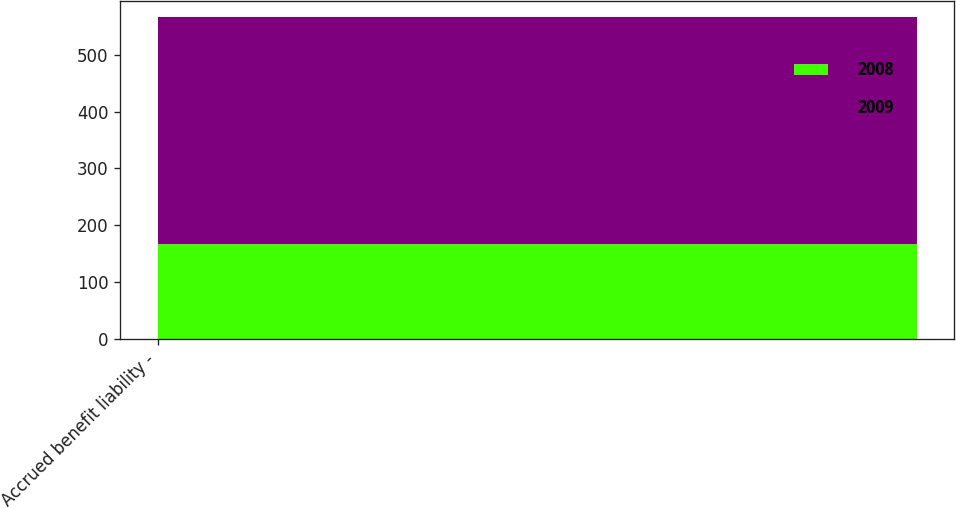Convert chart. <chart><loc_0><loc_0><loc_500><loc_500><stacked_bar_chart><ecel><fcel>Accrued benefit liability -<nl><fcel>2008<fcel>167<nl><fcel>2009<fcel>399<nl></chart> 